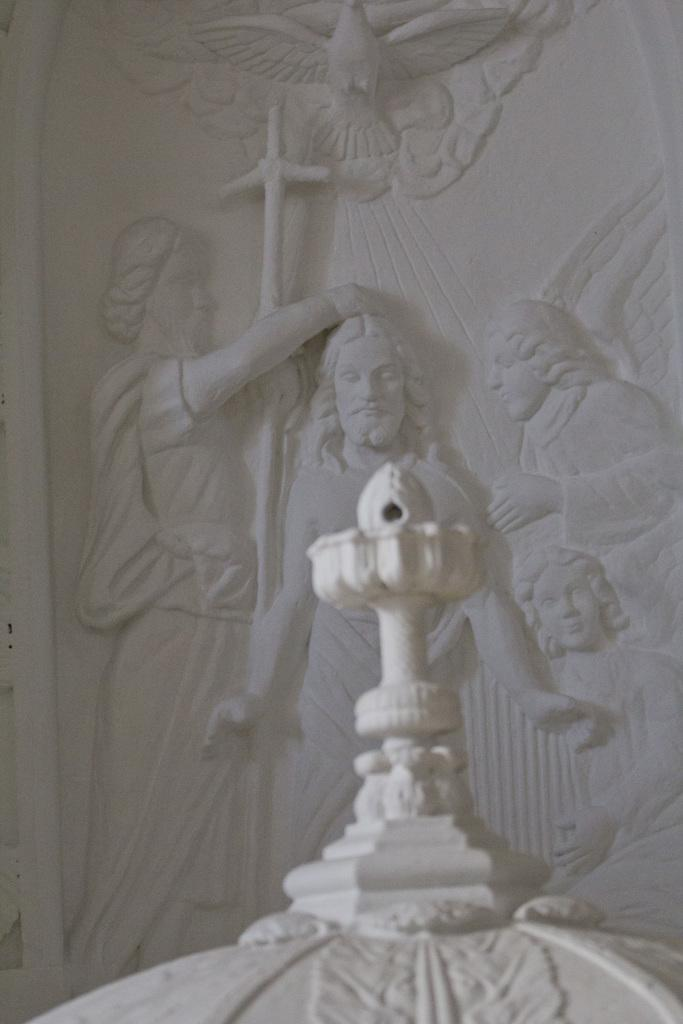What is the main subject of the image? There is a statue in the image. Can you describe the statue? The statue appears to depict Jesus Christ. How many geese are visible in the image? There are no geese present in the image; it features a statue of Jesus Christ. What type of camera is being used to take the picture? There is no information about a camera being used to take the picture, as the focus is on the statue in the image. 